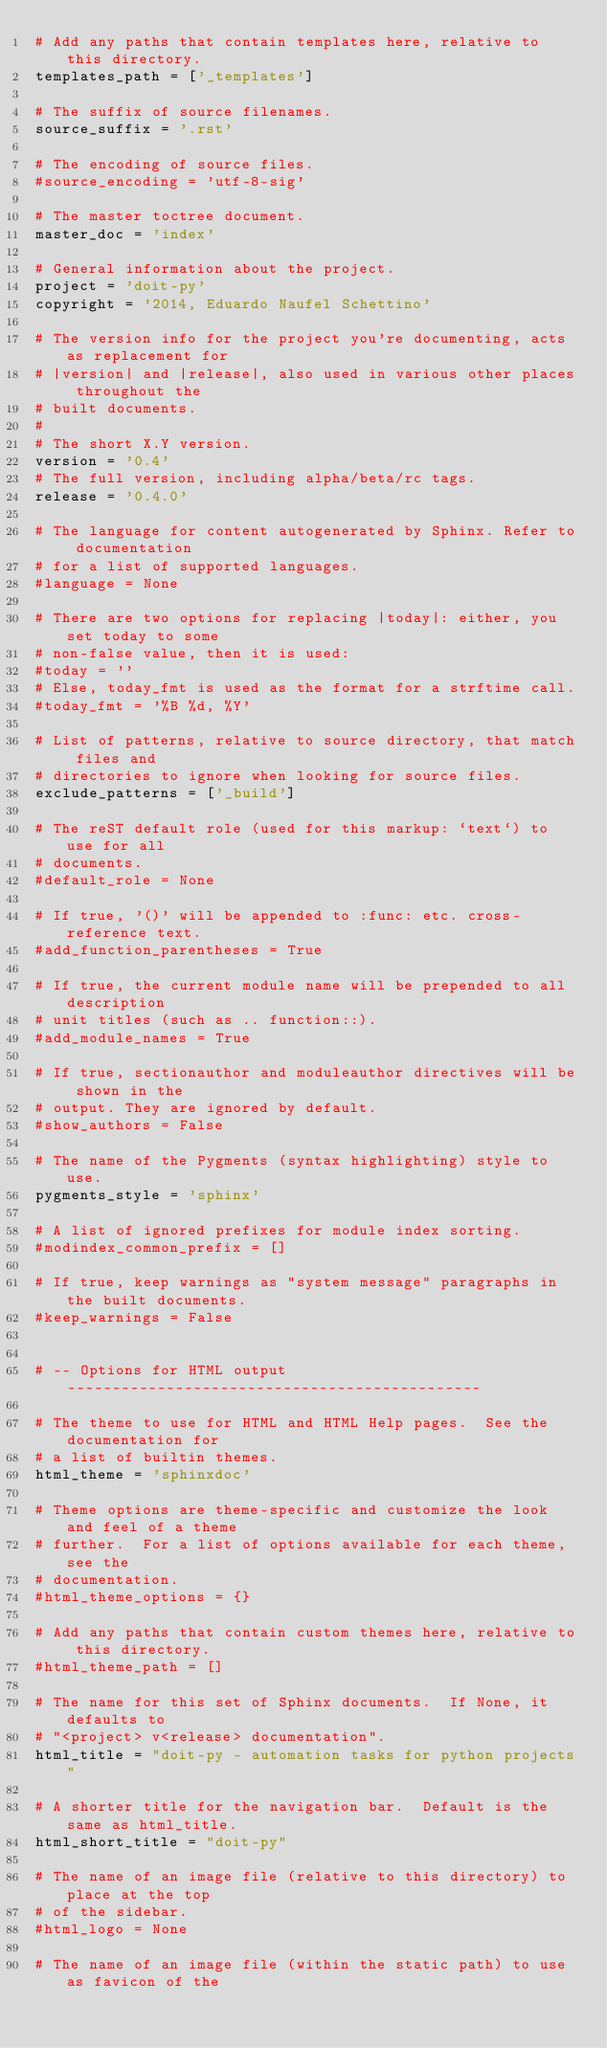<code> <loc_0><loc_0><loc_500><loc_500><_Python_># Add any paths that contain templates here, relative to this directory.
templates_path = ['_templates']

# The suffix of source filenames.
source_suffix = '.rst'

# The encoding of source files.
#source_encoding = 'utf-8-sig'

# The master toctree document.
master_doc = 'index'

# General information about the project.
project = 'doit-py'
copyright = '2014, Eduardo Naufel Schettino'

# The version info for the project you're documenting, acts as replacement for
# |version| and |release|, also used in various other places throughout the
# built documents.
#
# The short X.Y version.
version = '0.4'
# The full version, including alpha/beta/rc tags.
release = '0.4.0'

# The language for content autogenerated by Sphinx. Refer to documentation
# for a list of supported languages.
#language = None

# There are two options for replacing |today|: either, you set today to some
# non-false value, then it is used:
#today = ''
# Else, today_fmt is used as the format for a strftime call.
#today_fmt = '%B %d, %Y'

# List of patterns, relative to source directory, that match files and
# directories to ignore when looking for source files.
exclude_patterns = ['_build']

# The reST default role (used for this markup: `text`) to use for all
# documents.
#default_role = None

# If true, '()' will be appended to :func: etc. cross-reference text.
#add_function_parentheses = True

# If true, the current module name will be prepended to all description
# unit titles (such as .. function::).
#add_module_names = True

# If true, sectionauthor and moduleauthor directives will be shown in the
# output. They are ignored by default.
#show_authors = False

# The name of the Pygments (syntax highlighting) style to use.
pygments_style = 'sphinx'

# A list of ignored prefixes for module index sorting.
#modindex_common_prefix = []

# If true, keep warnings as "system message" paragraphs in the built documents.
#keep_warnings = False


# -- Options for HTML output ----------------------------------------------

# The theme to use for HTML and HTML Help pages.  See the documentation for
# a list of builtin themes.
html_theme = 'sphinxdoc'

# Theme options are theme-specific and customize the look and feel of a theme
# further.  For a list of options available for each theme, see the
# documentation.
#html_theme_options = {}

# Add any paths that contain custom themes here, relative to this directory.
#html_theme_path = []

# The name for this set of Sphinx documents.  If None, it defaults to
# "<project> v<release> documentation".
html_title = "doit-py - automation tasks for python projects"

# A shorter title for the navigation bar.  Default is the same as html_title.
html_short_title = "doit-py"

# The name of an image file (relative to this directory) to place at the top
# of the sidebar.
#html_logo = None

# The name of an image file (within the static path) to use as favicon of the</code> 